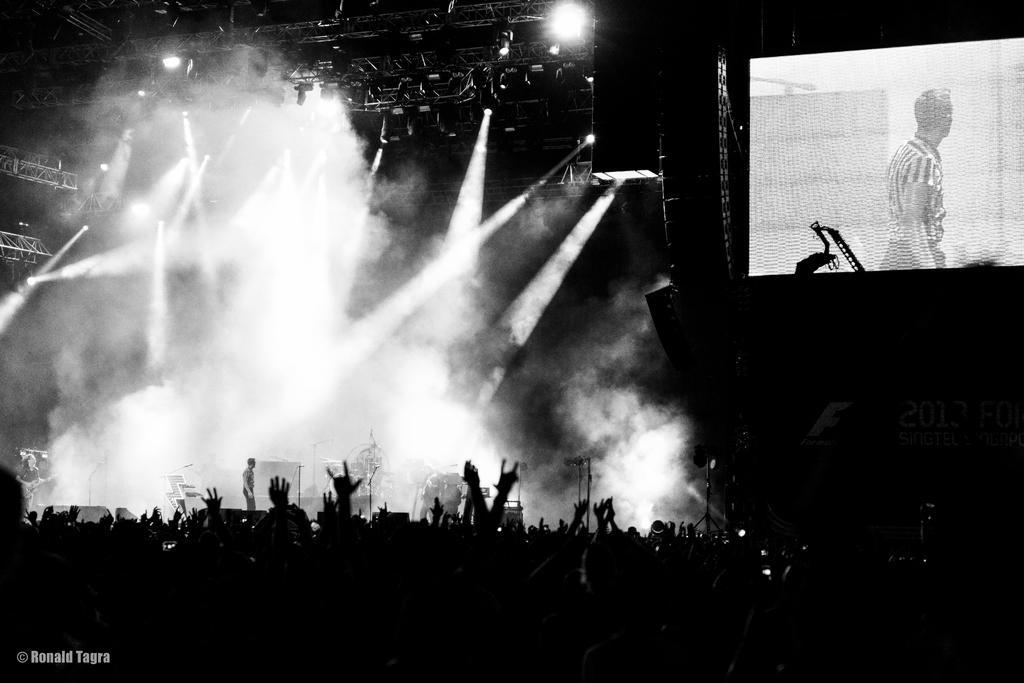Could you give a brief overview of what you see in this image? In this picture there is a screen on the right side of the image and there is a stage on the left side of the image, there are audience at the bottom side of the image and there is a person who is standing on the stage on the left side of the image, there are spotlights at the top side of the image. 